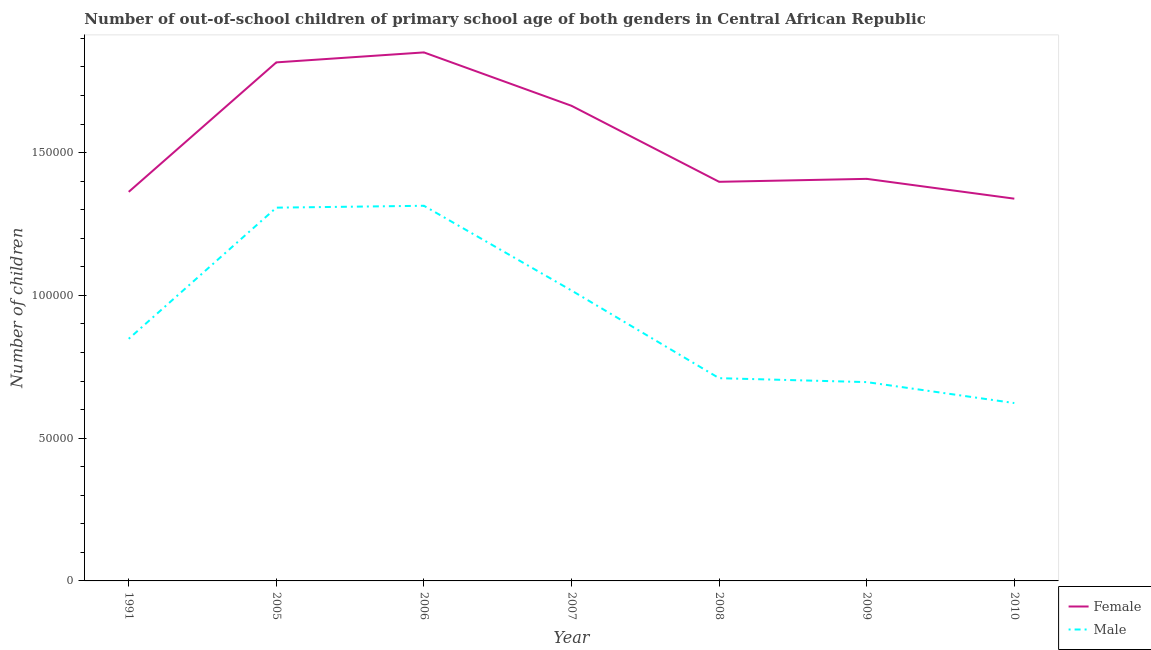How many different coloured lines are there?
Keep it short and to the point. 2. Is the number of lines equal to the number of legend labels?
Provide a short and direct response. Yes. What is the number of female out-of-school students in 2008?
Provide a succinct answer. 1.40e+05. Across all years, what is the maximum number of male out-of-school students?
Your answer should be very brief. 1.31e+05. Across all years, what is the minimum number of female out-of-school students?
Give a very brief answer. 1.34e+05. In which year was the number of male out-of-school students maximum?
Your answer should be compact. 2006. What is the total number of male out-of-school students in the graph?
Your response must be concise. 6.52e+05. What is the difference between the number of female out-of-school students in 2006 and that in 2007?
Provide a succinct answer. 1.87e+04. What is the difference between the number of male out-of-school students in 2007 and the number of female out-of-school students in 2010?
Give a very brief answer. -3.22e+04. What is the average number of female out-of-school students per year?
Provide a succinct answer. 1.55e+05. In the year 2006, what is the difference between the number of female out-of-school students and number of male out-of-school students?
Provide a short and direct response. 5.37e+04. In how many years, is the number of female out-of-school students greater than 110000?
Your response must be concise. 7. What is the ratio of the number of male out-of-school students in 2006 to that in 2009?
Ensure brevity in your answer.  1.89. Is the number of male out-of-school students in 2006 less than that in 2008?
Your answer should be compact. No. Is the difference between the number of male out-of-school students in 2006 and 2010 greater than the difference between the number of female out-of-school students in 2006 and 2010?
Give a very brief answer. Yes. What is the difference between the highest and the second highest number of female out-of-school students?
Ensure brevity in your answer.  3494. What is the difference between the highest and the lowest number of male out-of-school students?
Make the answer very short. 6.91e+04. In how many years, is the number of female out-of-school students greater than the average number of female out-of-school students taken over all years?
Keep it short and to the point. 3. Is the sum of the number of female out-of-school students in 1991 and 2006 greater than the maximum number of male out-of-school students across all years?
Make the answer very short. Yes. Does the number of male out-of-school students monotonically increase over the years?
Your answer should be very brief. No. Is the number of male out-of-school students strictly greater than the number of female out-of-school students over the years?
Your answer should be very brief. No. How many lines are there?
Your response must be concise. 2. What is the difference between two consecutive major ticks on the Y-axis?
Provide a short and direct response. 5.00e+04. Are the values on the major ticks of Y-axis written in scientific E-notation?
Provide a succinct answer. No. Does the graph contain grids?
Give a very brief answer. No. Where does the legend appear in the graph?
Your answer should be compact. Bottom right. How many legend labels are there?
Your response must be concise. 2. How are the legend labels stacked?
Your response must be concise. Vertical. What is the title of the graph?
Make the answer very short. Number of out-of-school children of primary school age of both genders in Central African Republic. Does "Largest city" appear as one of the legend labels in the graph?
Make the answer very short. No. What is the label or title of the X-axis?
Keep it short and to the point. Year. What is the label or title of the Y-axis?
Make the answer very short. Number of children. What is the Number of children in Female in 1991?
Make the answer very short. 1.36e+05. What is the Number of children in Male in 1991?
Offer a very short reply. 8.48e+04. What is the Number of children in Female in 2005?
Ensure brevity in your answer.  1.82e+05. What is the Number of children in Male in 2005?
Make the answer very short. 1.31e+05. What is the Number of children in Female in 2006?
Ensure brevity in your answer.  1.85e+05. What is the Number of children of Male in 2006?
Keep it short and to the point. 1.31e+05. What is the Number of children in Female in 2007?
Provide a short and direct response. 1.66e+05. What is the Number of children in Male in 2007?
Offer a terse response. 1.02e+05. What is the Number of children of Female in 2008?
Give a very brief answer. 1.40e+05. What is the Number of children in Male in 2008?
Make the answer very short. 7.10e+04. What is the Number of children in Female in 2009?
Your answer should be compact. 1.41e+05. What is the Number of children in Male in 2009?
Offer a very short reply. 6.96e+04. What is the Number of children in Female in 2010?
Make the answer very short. 1.34e+05. What is the Number of children in Male in 2010?
Give a very brief answer. 6.23e+04. Across all years, what is the maximum Number of children of Female?
Offer a terse response. 1.85e+05. Across all years, what is the maximum Number of children in Male?
Provide a succinct answer. 1.31e+05. Across all years, what is the minimum Number of children of Female?
Keep it short and to the point. 1.34e+05. Across all years, what is the minimum Number of children in Male?
Ensure brevity in your answer.  6.23e+04. What is the total Number of children of Female in the graph?
Give a very brief answer. 1.08e+06. What is the total Number of children in Male in the graph?
Provide a short and direct response. 6.52e+05. What is the difference between the Number of children in Female in 1991 and that in 2005?
Ensure brevity in your answer.  -4.53e+04. What is the difference between the Number of children in Male in 1991 and that in 2005?
Give a very brief answer. -4.59e+04. What is the difference between the Number of children in Female in 1991 and that in 2006?
Offer a terse response. -4.88e+04. What is the difference between the Number of children of Male in 1991 and that in 2006?
Give a very brief answer. -4.66e+04. What is the difference between the Number of children in Female in 1991 and that in 2007?
Make the answer very short. -3.01e+04. What is the difference between the Number of children in Male in 1991 and that in 2007?
Give a very brief answer. -1.69e+04. What is the difference between the Number of children of Female in 1991 and that in 2008?
Your answer should be compact. -3520. What is the difference between the Number of children in Male in 1991 and that in 2008?
Make the answer very short. 1.38e+04. What is the difference between the Number of children of Female in 1991 and that in 2009?
Your answer should be very brief. -4554. What is the difference between the Number of children in Male in 1991 and that in 2009?
Provide a short and direct response. 1.52e+04. What is the difference between the Number of children in Female in 1991 and that in 2010?
Provide a succinct answer. 2387. What is the difference between the Number of children of Male in 1991 and that in 2010?
Make the answer very short. 2.25e+04. What is the difference between the Number of children in Female in 2005 and that in 2006?
Offer a very short reply. -3494. What is the difference between the Number of children of Male in 2005 and that in 2006?
Provide a short and direct response. -657. What is the difference between the Number of children of Female in 2005 and that in 2007?
Your response must be concise. 1.52e+04. What is the difference between the Number of children in Male in 2005 and that in 2007?
Make the answer very short. 2.90e+04. What is the difference between the Number of children in Female in 2005 and that in 2008?
Offer a terse response. 4.18e+04. What is the difference between the Number of children in Male in 2005 and that in 2008?
Your response must be concise. 5.97e+04. What is the difference between the Number of children in Female in 2005 and that in 2009?
Your response must be concise. 4.08e+04. What is the difference between the Number of children of Male in 2005 and that in 2009?
Offer a very short reply. 6.11e+04. What is the difference between the Number of children in Female in 2005 and that in 2010?
Ensure brevity in your answer.  4.77e+04. What is the difference between the Number of children in Male in 2005 and that in 2010?
Give a very brief answer. 6.84e+04. What is the difference between the Number of children in Female in 2006 and that in 2007?
Keep it short and to the point. 1.87e+04. What is the difference between the Number of children in Male in 2006 and that in 2007?
Make the answer very short. 2.97e+04. What is the difference between the Number of children of Female in 2006 and that in 2008?
Provide a succinct answer. 4.53e+04. What is the difference between the Number of children in Male in 2006 and that in 2008?
Offer a terse response. 6.04e+04. What is the difference between the Number of children of Female in 2006 and that in 2009?
Provide a succinct answer. 4.43e+04. What is the difference between the Number of children of Male in 2006 and that in 2009?
Offer a very short reply. 6.18e+04. What is the difference between the Number of children of Female in 2006 and that in 2010?
Keep it short and to the point. 5.12e+04. What is the difference between the Number of children in Male in 2006 and that in 2010?
Make the answer very short. 6.91e+04. What is the difference between the Number of children of Female in 2007 and that in 2008?
Offer a very short reply. 2.66e+04. What is the difference between the Number of children of Male in 2007 and that in 2008?
Keep it short and to the point. 3.07e+04. What is the difference between the Number of children of Female in 2007 and that in 2009?
Ensure brevity in your answer.  2.56e+04. What is the difference between the Number of children of Male in 2007 and that in 2009?
Keep it short and to the point. 3.21e+04. What is the difference between the Number of children of Female in 2007 and that in 2010?
Offer a very short reply. 3.25e+04. What is the difference between the Number of children of Male in 2007 and that in 2010?
Provide a succinct answer. 3.94e+04. What is the difference between the Number of children of Female in 2008 and that in 2009?
Offer a very short reply. -1034. What is the difference between the Number of children in Male in 2008 and that in 2009?
Offer a terse response. 1376. What is the difference between the Number of children in Female in 2008 and that in 2010?
Your answer should be compact. 5907. What is the difference between the Number of children of Male in 2008 and that in 2010?
Offer a very short reply. 8711. What is the difference between the Number of children of Female in 2009 and that in 2010?
Ensure brevity in your answer.  6941. What is the difference between the Number of children of Male in 2009 and that in 2010?
Make the answer very short. 7335. What is the difference between the Number of children in Female in 1991 and the Number of children in Male in 2005?
Offer a terse response. 5529. What is the difference between the Number of children of Female in 1991 and the Number of children of Male in 2006?
Ensure brevity in your answer.  4872. What is the difference between the Number of children in Female in 1991 and the Number of children in Male in 2007?
Your answer should be very brief. 3.45e+04. What is the difference between the Number of children of Female in 1991 and the Number of children of Male in 2008?
Ensure brevity in your answer.  6.53e+04. What is the difference between the Number of children of Female in 1991 and the Number of children of Male in 2009?
Make the answer very short. 6.66e+04. What is the difference between the Number of children in Female in 1991 and the Number of children in Male in 2010?
Your answer should be compact. 7.40e+04. What is the difference between the Number of children in Female in 2005 and the Number of children in Male in 2006?
Make the answer very short. 5.02e+04. What is the difference between the Number of children of Female in 2005 and the Number of children of Male in 2007?
Your answer should be compact. 7.99e+04. What is the difference between the Number of children in Female in 2005 and the Number of children in Male in 2008?
Make the answer very short. 1.11e+05. What is the difference between the Number of children in Female in 2005 and the Number of children in Male in 2009?
Ensure brevity in your answer.  1.12e+05. What is the difference between the Number of children in Female in 2005 and the Number of children in Male in 2010?
Offer a very short reply. 1.19e+05. What is the difference between the Number of children of Female in 2006 and the Number of children of Male in 2007?
Your response must be concise. 8.34e+04. What is the difference between the Number of children in Female in 2006 and the Number of children in Male in 2008?
Your answer should be compact. 1.14e+05. What is the difference between the Number of children in Female in 2006 and the Number of children in Male in 2009?
Provide a short and direct response. 1.15e+05. What is the difference between the Number of children of Female in 2006 and the Number of children of Male in 2010?
Your response must be concise. 1.23e+05. What is the difference between the Number of children of Female in 2007 and the Number of children of Male in 2008?
Your response must be concise. 9.54e+04. What is the difference between the Number of children of Female in 2007 and the Number of children of Male in 2009?
Make the answer very short. 9.68e+04. What is the difference between the Number of children of Female in 2007 and the Number of children of Male in 2010?
Offer a terse response. 1.04e+05. What is the difference between the Number of children in Female in 2008 and the Number of children in Male in 2009?
Ensure brevity in your answer.  7.01e+04. What is the difference between the Number of children in Female in 2008 and the Number of children in Male in 2010?
Keep it short and to the point. 7.75e+04. What is the difference between the Number of children of Female in 2009 and the Number of children of Male in 2010?
Offer a very short reply. 7.85e+04. What is the average Number of children of Female per year?
Ensure brevity in your answer.  1.55e+05. What is the average Number of children of Male per year?
Offer a very short reply. 9.31e+04. In the year 1991, what is the difference between the Number of children of Female and Number of children of Male?
Make the answer very short. 5.15e+04. In the year 2005, what is the difference between the Number of children of Female and Number of children of Male?
Offer a very short reply. 5.09e+04. In the year 2006, what is the difference between the Number of children in Female and Number of children in Male?
Keep it short and to the point. 5.37e+04. In the year 2007, what is the difference between the Number of children in Female and Number of children in Male?
Your response must be concise. 6.47e+04. In the year 2008, what is the difference between the Number of children of Female and Number of children of Male?
Ensure brevity in your answer.  6.88e+04. In the year 2009, what is the difference between the Number of children of Female and Number of children of Male?
Provide a short and direct response. 7.12e+04. In the year 2010, what is the difference between the Number of children of Female and Number of children of Male?
Offer a terse response. 7.16e+04. What is the ratio of the Number of children of Female in 1991 to that in 2005?
Keep it short and to the point. 0.75. What is the ratio of the Number of children in Male in 1991 to that in 2005?
Make the answer very short. 0.65. What is the ratio of the Number of children in Female in 1991 to that in 2006?
Your answer should be compact. 0.74. What is the ratio of the Number of children of Male in 1991 to that in 2006?
Offer a terse response. 0.65. What is the ratio of the Number of children in Female in 1991 to that in 2007?
Keep it short and to the point. 0.82. What is the ratio of the Number of children in Male in 1991 to that in 2007?
Your response must be concise. 0.83. What is the ratio of the Number of children of Female in 1991 to that in 2008?
Your answer should be very brief. 0.97. What is the ratio of the Number of children of Male in 1991 to that in 2008?
Offer a terse response. 1.19. What is the ratio of the Number of children of Male in 1991 to that in 2009?
Offer a very short reply. 1.22. What is the ratio of the Number of children of Female in 1991 to that in 2010?
Provide a succinct answer. 1.02. What is the ratio of the Number of children in Male in 1991 to that in 2010?
Your answer should be compact. 1.36. What is the ratio of the Number of children in Female in 2005 to that in 2006?
Your answer should be very brief. 0.98. What is the ratio of the Number of children of Male in 2005 to that in 2006?
Provide a succinct answer. 0.99. What is the ratio of the Number of children of Female in 2005 to that in 2007?
Give a very brief answer. 1.09. What is the ratio of the Number of children of Male in 2005 to that in 2007?
Provide a succinct answer. 1.29. What is the ratio of the Number of children in Female in 2005 to that in 2008?
Offer a terse response. 1.3. What is the ratio of the Number of children of Male in 2005 to that in 2008?
Your answer should be very brief. 1.84. What is the ratio of the Number of children in Female in 2005 to that in 2009?
Your answer should be compact. 1.29. What is the ratio of the Number of children in Male in 2005 to that in 2009?
Give a very brief answer. 1.88. What is the ratio of the Number of children in Female in 2005 to that in 2010?
Provide a short and direct response. 1.36. What is the ratio of the Number of children of Male in 2005 to that in 2010?
Your answer should be very brief. 2.1. What is the ratio of the Number of children in Female in 2006 to that in 2007?
Provide a short and direct response. 1.11. What is the ratio of the Number of children in Male in 2006 to that in 2007?
Your response must be concise. 1.29. What is the ratio of the Number of children of Female in 2006 to that in 2008?
Offer a very short reply. 1.32. What is the ratio of the Number of children in Male in 2006 to that in 2008?
Your answer should be very brief. 1.85. What is the ratio of the Number of children of Female in 2006 to that in 2009?
Keep it short and to the point. 1.31. What is the ratio of the Number of children in Male in 2006 to that in 2009?
Your response must be concise. 1.89. What is the ratio of the Number of children of Female in 2006 to that in 2010?
Provide a short and direct response. 1.38. What is the ratio of the Number of children in Male in 2006 to that in 2010?
Offer a terse response. 2.11. What is the ratio of the Number of children in Female in 2007 to that in 2008?
Provide a short and direct response. 1.19. What is the ratio of the Number of children in Male in 2007 to that in 2008?
Give a very brief answer. 1.43. What is the ratio of the Number of children in Female in 2007 to that in 2009?
Ensure brevity in your answer.  1.18. What is the ratio of the Number of children in Male in 2007 to that in 2009?
Give a very brief answer. 1.46. What is the ratio of the Number of children of Female in 2007 to that in 2010?
Make the answer very short. 1.24. What is the ratio of the Number of children of Male in 2007 to that in 2010?
Your answer should be very brief. 1.63. What is the ratio of the Number of children in Female in 2008 to that in 2009?
Your answer should be compact. 0.99. What is the ratio of the Number of children in Male in 2008 to that in 2009?
Your answer should be very brief. 1.02. What is the ratio of the Number of children of Female in 2008 to that in 2010?
Provide a short and direct response. 1.04. What is the ratio of the Number of children in Male in 2008 to that in 2010?
Your response must be concise. 1.14. What is the ratio of the Number of children in Female in 2009 to that in 2010?
Your response must be concise. 1.05. What is the ratio of the Number of children in Male in 2009 to that in 2010?
Keep it short and to the point. 1.12. What is the difference between the highest and the second highest Number of children of Female?
Provide a succinct answer. 3494. What is the difference between the highest and the second highest Number of children of Male?
Your response must be concise. 657. What is the difference between the highest and the lowest Number of children in Female?
Provide a succinct answer. 5.12e+04. What is the difference between the highest and the lowest Number of children of Male?
Offer a very short reply. 6.91e+04. 